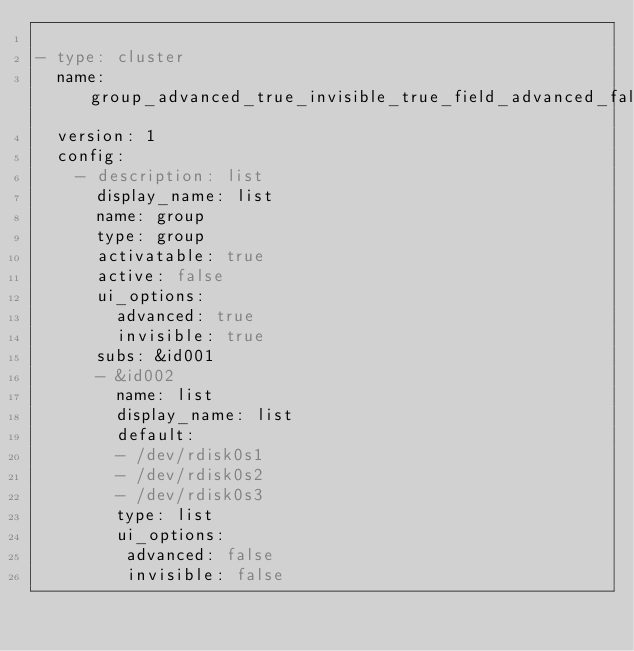Convert code to text. <code><loc_0><loc_0><loc_500><loc_500><_YAML_>
- type: cluster
  name: group_advanced_true_invisible_true_field_advanced_false_invisible_false_activatable_false_list
  version: 1
  config:
    - description: list
      display_name: list
      name: group
      type: group
      activatable: true
      active: false
      ui_options:
        advanced: true
        invisible: true
      subs: &id001
      - &id002
        name: list
        display_name: list
        default:
        - /dev/rdisk0s1
        - /dev/rdisk0s2
        - /dev/rdisk0s3
        type: list
        ui_options:
         advanced: false
         invisible: false
</code> 